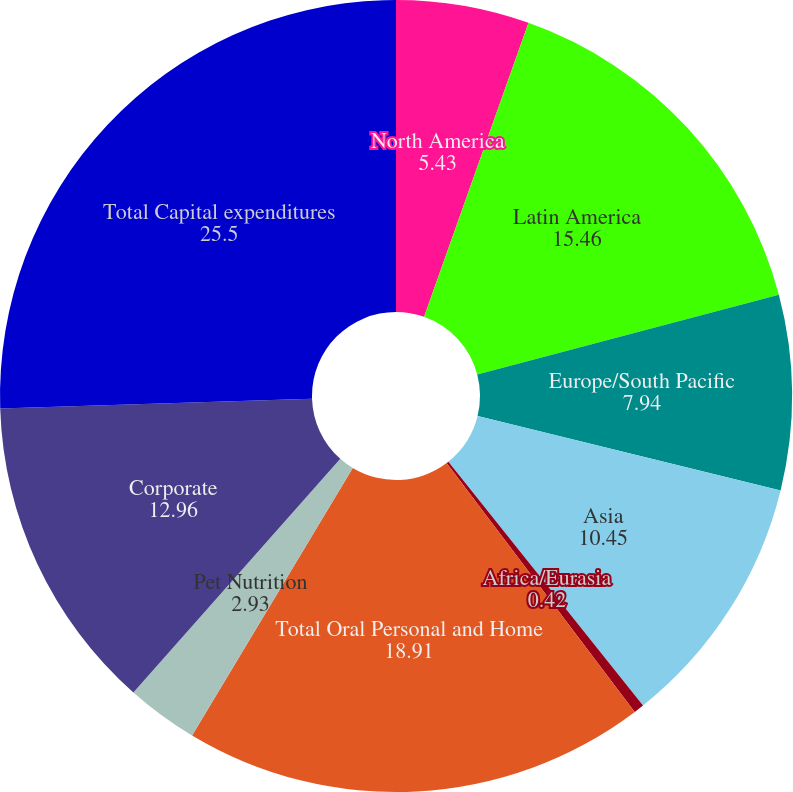Convert chart to OTSL. <chart><loc_0><loc_0><loc_500><loc_500><pie_chart><fcel>North America<fcel>Latin America<fcel>Europe/South Pacific<fcel>Asia<fcel>Africa/Eurasia<fcel>Total Oral Personal and Home<fcel>Pet Nutrition<fcel>Corporate<fcel>Total Capital expenditures<nl><fcel>5.43%<fcel>15.46%<fcel>7.94%<fcel>10.45%<fcel>0.42%<fcel>18.91%<fcel>2.93%<fcel>12.96%<fcel>25.5%<nl></chart> 